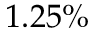Convert formula to latex. <formula><loc_0><loc_0><loc_500><loc_500>1 . 2 5 \%</formula> 